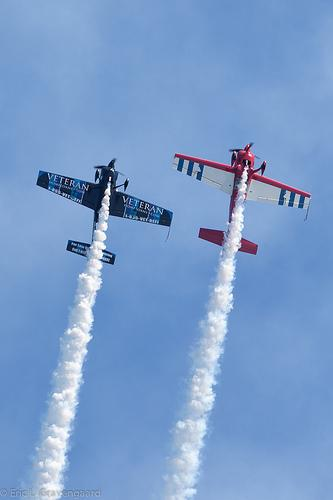What are the main colors seen on the planes in the image? The main colors on the planes are red, white, and blue. Identify the primary objects in the image and how they interact. The primary objects are the two airplanes with red, white, and blue colors, and they interact by flying alongside each other, leaving trails of smoke in the sky. Please describe the environment in which the airplanes are flying. The airplanes are flying in a lightly cloudy blue sky. In your own words, explain the distinguishing features of each airplane. One airplane has blue striped wings, while the other has a red and white body. Both have the word "veteran" written on their wings, and they have nose propellers. Describe the trajectories of both planes and their smoke. Both planes are climbing skyward, and they are leaving trails of smoke behind them. Describe the sentiment evoked from the image. The image conveys a sense of excitement, adventure, and patriotism with the planes soaring in the sky and their vibrant colors. Indicate how many airplanes appear in this image. There are two airplanes in the image. Analyze the quality of the image, mentioning if any objects or text are blurry or hard to read. The image is of high quality with clear objects and text, making it easy to read the text on the planes' wings and to distinguish the planes' details. 